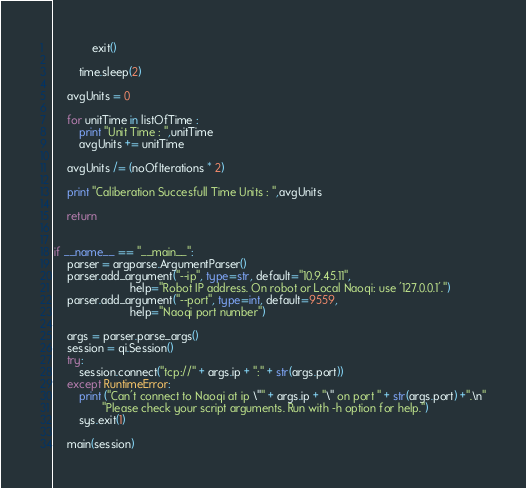<code> <loc_0><loc_0><loc_500><loc_500><_Python_>            exit()

        time.sleep(2)

    avgUnits = 0

    for unitTime in listOfTime :
        print "Unit Time : ",unitTime
        avgUnits += unitTime

    avgUnits /= (noOfIterations * 2)

    print "Caliberation Succesfull Time Units : ",avgUnits

    return


if __name__ == "__main__":
    parser = argparse.ArgumentParser()
    parser.add_argument("--ip", type=str, default="10.9.45.11",
                        help="Robot IP address. On robot or Local Naoqi: use '127.0.0.1'.")
    parser.add_argument("--port", type=int, default=9559,
                        help="Naoqi port number")

    args = parser.parse_args()
    session = qi.Session()
    try:
        session.connect("tcp://" + args.ip + ":" + str(args.port))
    except RuntimeError:
        print ("Can't connect to Naoqi at ip \"" + args.ip + "\" on port " + str(args.port) +".\n"
               "Please check your script arguments. Run with -h option for help.")
        sys.exit(1)

    main(session)
</code> 